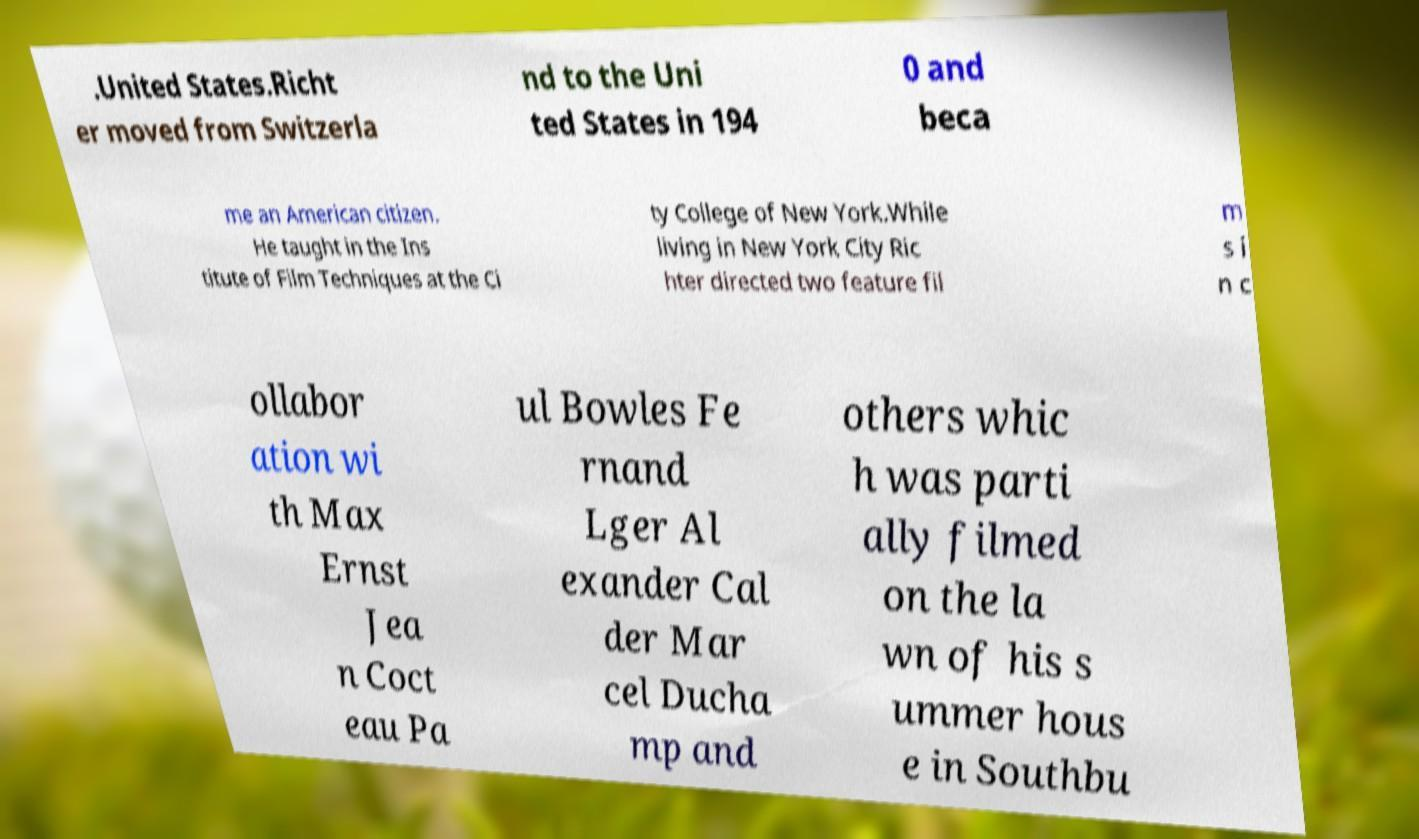Could you assist in decoding the text presented in this image and type it out clearly? .United States.Richt er moved from Switzerla nd to the Uni ted States in 194 0 and beca me an American citizen. He taught in the Ins titute of Film Techniques at the Ci ty College of New York.While living in New York City Ric hter directed two feature fil m s i n c ollabor ation wi th Max Ernst Jea n Coct eau Pa ul Bowles Fe rnand Lger Al exander Cal der Mar cel Ducha mp and others whic h was parti ally filmed on the la wn of his s ummer hous e in Southbu 